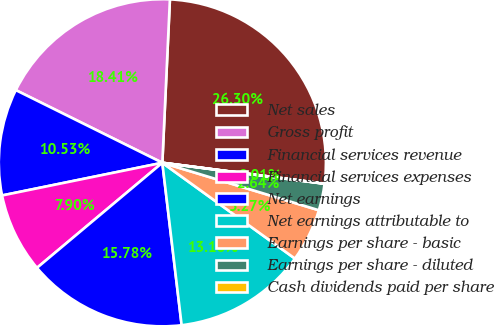Convert chart. <chart><loc_0><loc_0><loc_500><loc_500><pie_chart><fcel>Net sales<fcel>Gross profit<fcel>Financial services revenue<fcel>Financial services expenses<fcel>Net earnings<fcel>Net earnings attributable to<fcel>Earnings per share - basic<fcel>Earnings per share - diluted<fcel>Cash dividends paid per share<nl><fcel>26.3%<fcel>18.41%<fcel>10.53%<fcel>7.9%<fcel>15.78%<fcel>13.16%<fcel>5.27%<fcel>2.64%<fcel>0.01%<nl></chart> 